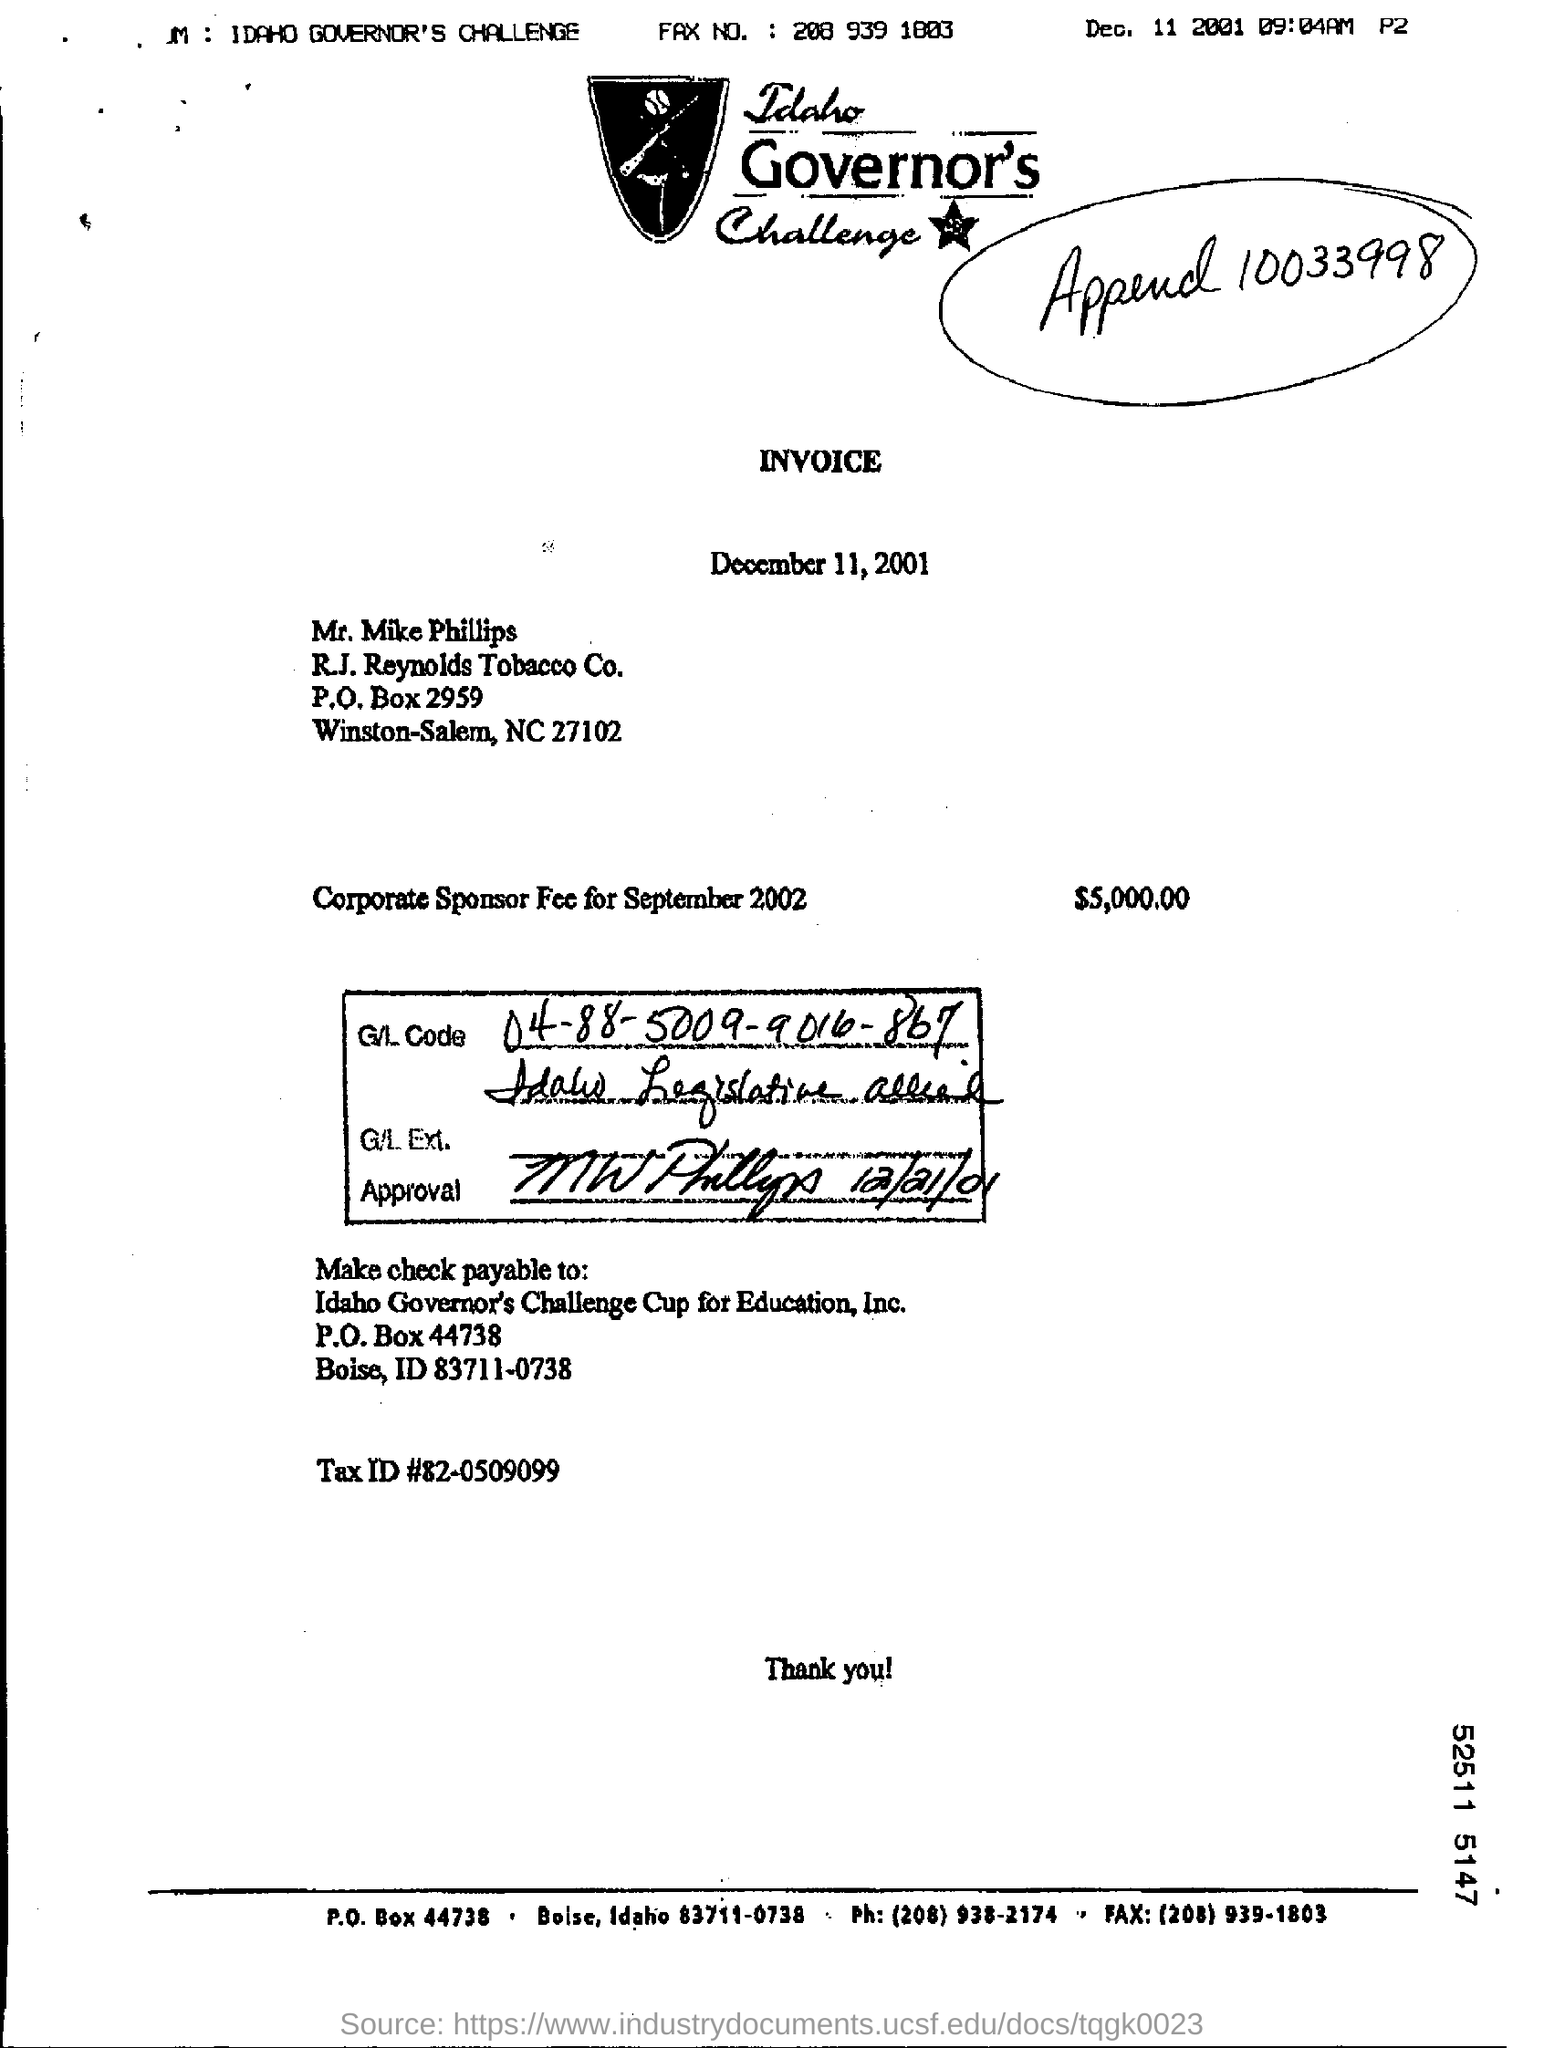What's the corporate sponsor fee for september 2002?
Offer a very short reply. $5,000.00. 